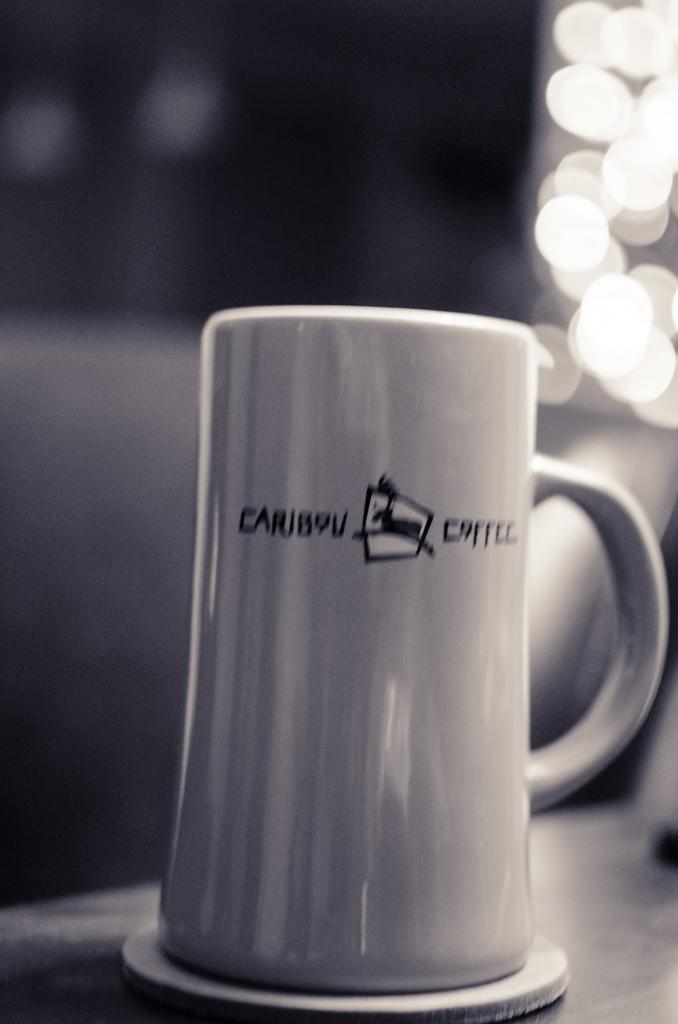What animal is referenced on the cup?
Offer a very short reply. Caribou. What kind of beverage is advertised on the mug?
Your answer should be compact. Caribou coffee. 